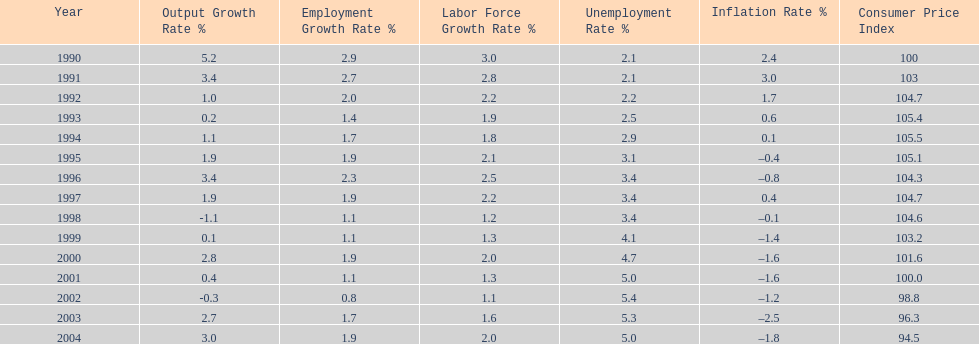Were the highest unemployment rates in japan before or after the year 2000? After. 